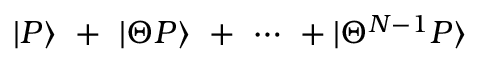<formula> <loc_0><loc_0><loc_500><loc_500>| P \rangle \ + \ | \Theta P \rangle \ + \ \cdots \ + | \Theta ^ { N - 1 } P \rangle</formula> 